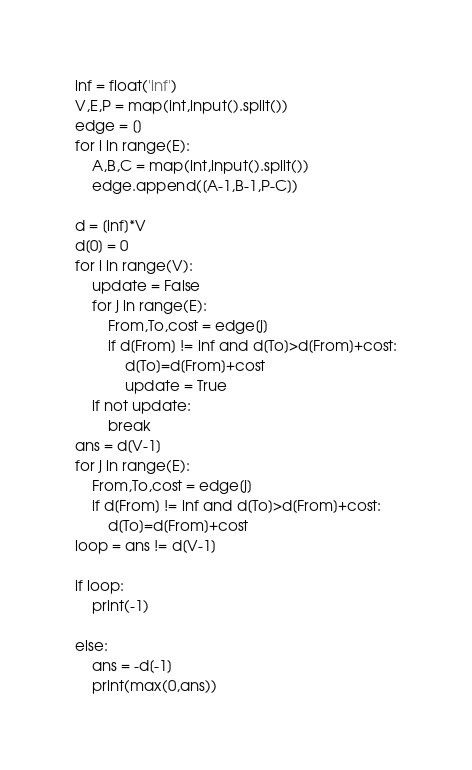<code> <loc_0><loc_0><loc_500><loc_500><_Python_>inf = float('inf')
V,E,P = map(int,input().split())
edge = []
for i in range(E):
    A,B,C = map(int,input().split())
    edge.append([A-1,B-1,P-C])

d = [inf]*V
d[0] = 0
for i in range(V):
    update = False
    for j in range(E):
        From,To,cost = edge[j]
        if d[From] != inf and d[To]>d[From]+cost:
            d[To]=d[From]+cost
            update = True
    if not update:
        break
ans = d[V-1]
for j in range(E):
    From,To,cost = edge[j]
    if d[From] != inf and d[To]>d[From]+cost:
        d[To]=d[From]+cost
loop = ans != d[V-1]

if loop:
    print(-1)

else:
    ans = -d[-1]
    print(max(0,ans))</code> 